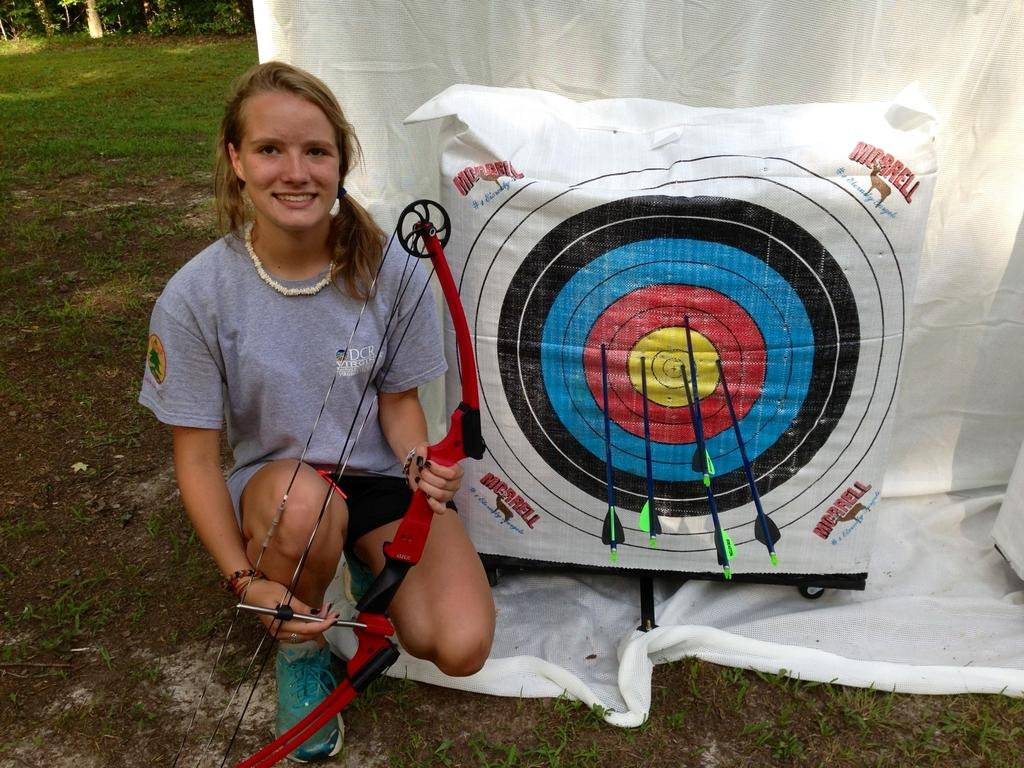Who is the main subject in the image? There is a lady in the image. What is the lady holding in her hands? The lady is holding an arrow in her hands. What is located beside the lady? There is a target board beside the lady. What can be seen in the background of the image? There is a white cloth and trees in the background of the image. What is the lady's income based on her activity in the image? The image does not provide any information about the lady's income, and her activity does not indicate a specific occupation or income source. 